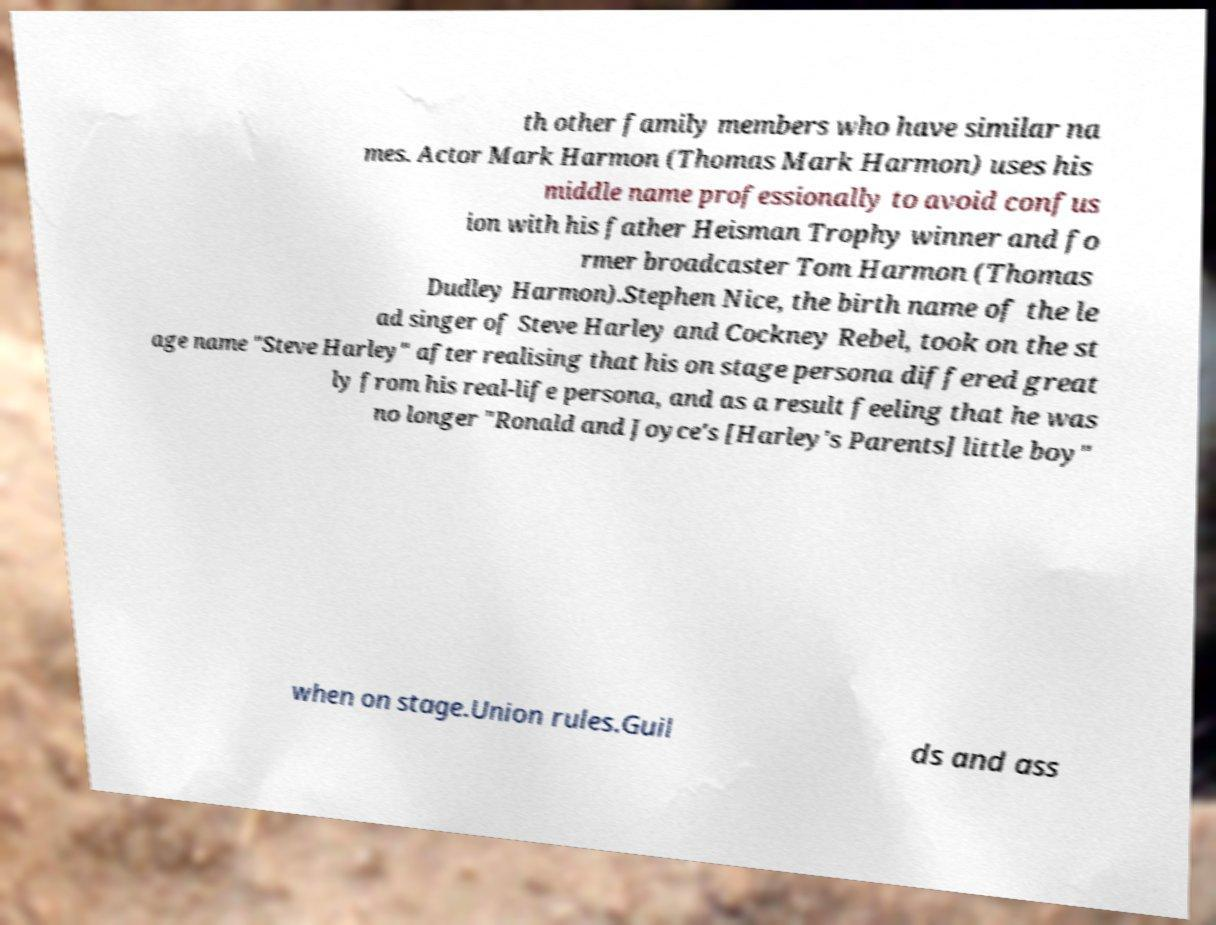Could you assist in decoding the text presented in this image and type it out clearly? th other family members who have similar na mes. Actor Mark Harmon (Thomas Mark Harmon) uses his middle name professionally to avoid confus ion with his father Heisman Trophy winner and fo rmer broadcaster Tom Harmon (Thomas Dudley Harmon).Stephen Nice, the birth name of the le ad singer of Steve Harley and Cockney Rebel, took on the st age name "Steve Harley" after realising that his on stage persona differed great ly from his real-life persona, and as a result feeling that he was no longer "Ronald and Joyce's [Harley's Parents] little boy" when on stage.Union rules.Guil ds and ass 